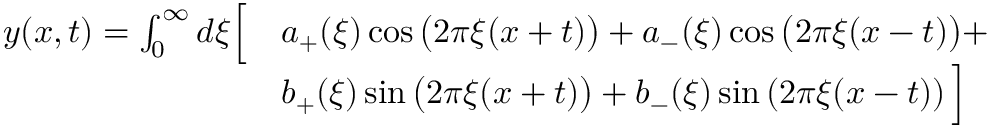Convert formula to latex. <formula><loc_0><loc_0><loc_500><loc_500>{ \begin{array} { r l } { y ( x , t ) = \int _ { 0 } ^ { \infty } d \xi { \left [ } } & { a _ { + } ( \xi ) \cos { \left ( } 2 \pi \xi ( x + t ) { \right ) } + a _ { - } ( \xi ) \cos { \left ( } 2 \pi \xi ( x - t ) { \right ) } + } \\ & { b _ { + } ( \xi ) \sin { \left ( } 2 \pi \xi ( x + t ) { \right ) } + b _ { - } ( \xi ) \sin \left ( 2 \pi \xi ( x - t ) \right ) { \right ] } } \end{array} }</formula> 